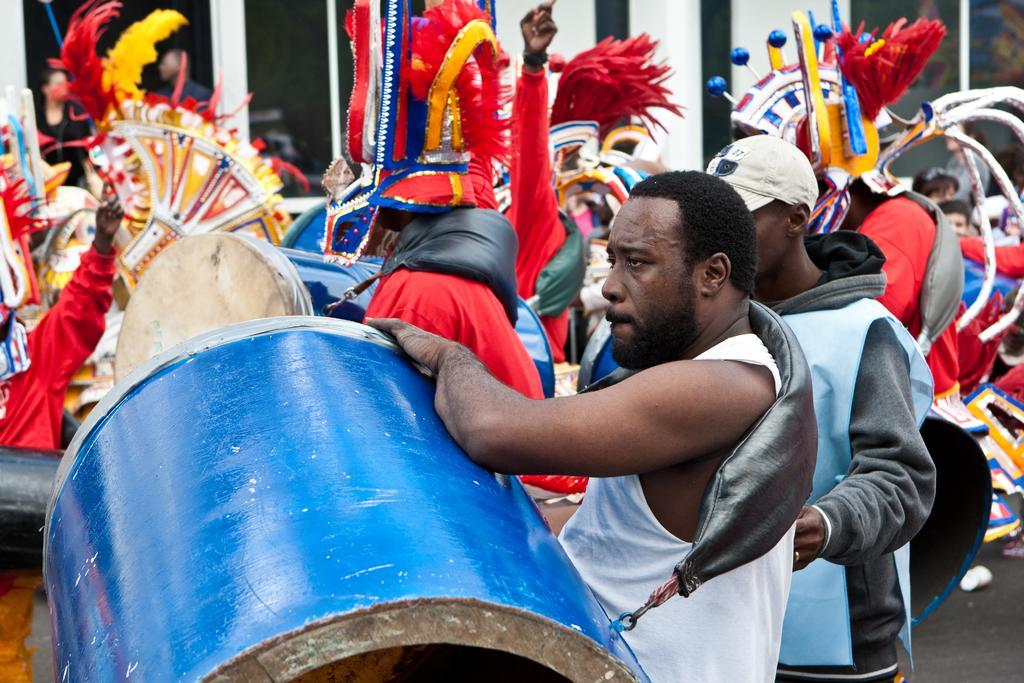Describe this image in one or two sentences. This image is clicked outside where there are so many people. They are wearing different kinds of dress and some of them are playing drums. 